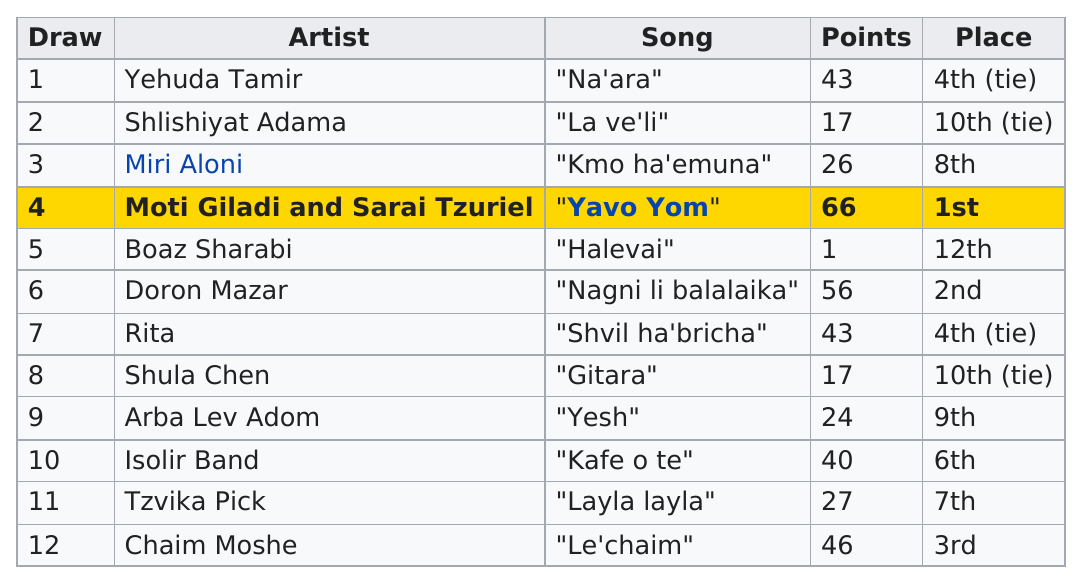Draw attention to some important aspects in this diagram. The song "yesh" earned more points than "gitara. The song 'Yavo Yom' earned the most points. Doron Mazar, a well-known artist, has been in the art industry for several years. Moti Giladi and Sarai Tzuriel, two other artists, have also been highly successful in their respective careers. Boaz Sharabi, an artist with very few points, had almost no points at all. The number of times an artist earned first place is 1. 